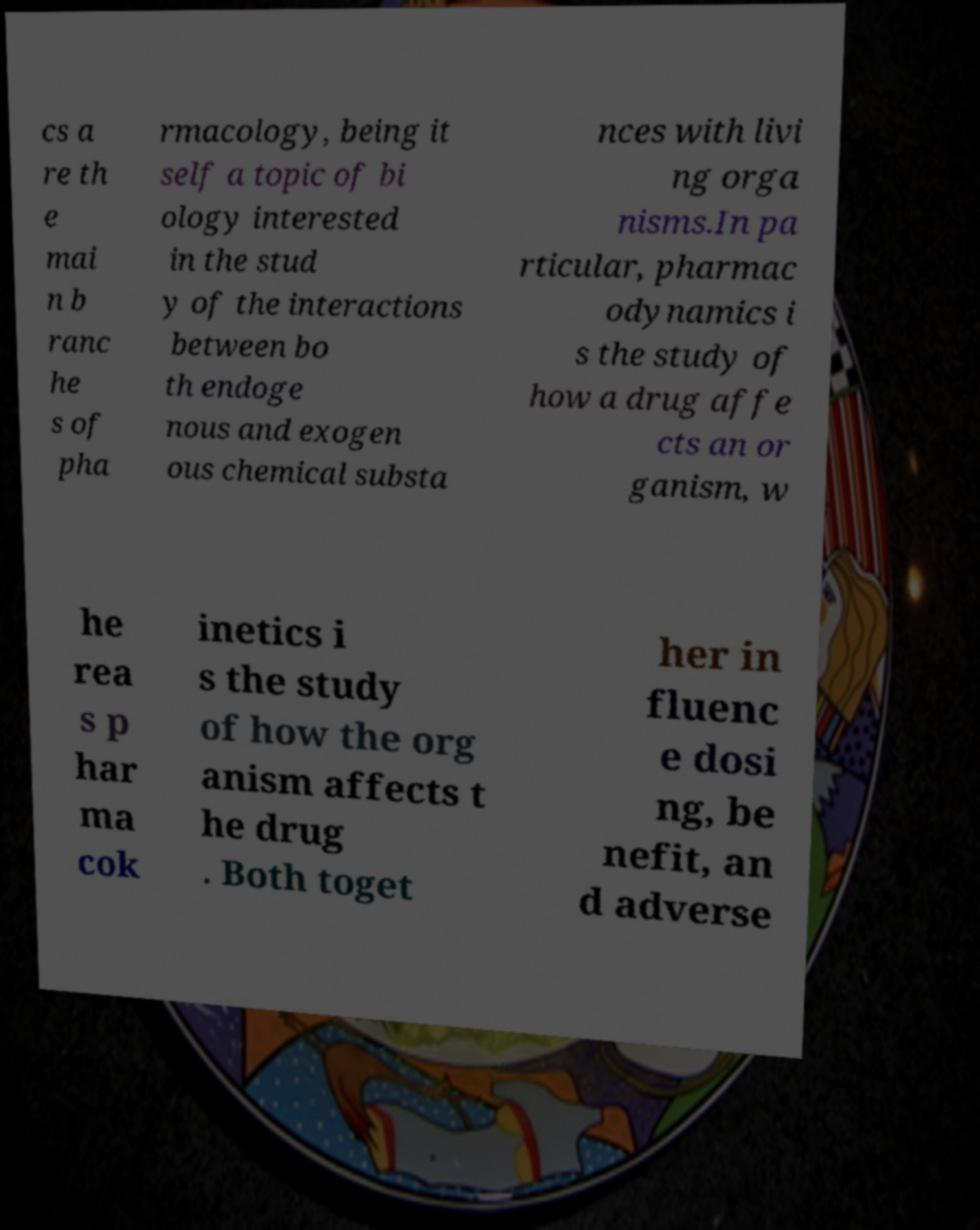Please identify and transcribe the text found in this image. cs a re th e mai n b ranc he s of pha rmacology, being it self a topic of bi ology interested in the stud y of the interactions between bo th endoge nous and exogen ous chemical substa nces with livi ng orga nisms.In pa rticular, pharmac odynamics i s the study of how a drug affe cts an or ganism, w he rea s p har ma cok inetics i s the study of how the org anism affects t he drug . Both toget her in fluenc e dosi ng, be nefit, an d adverse 